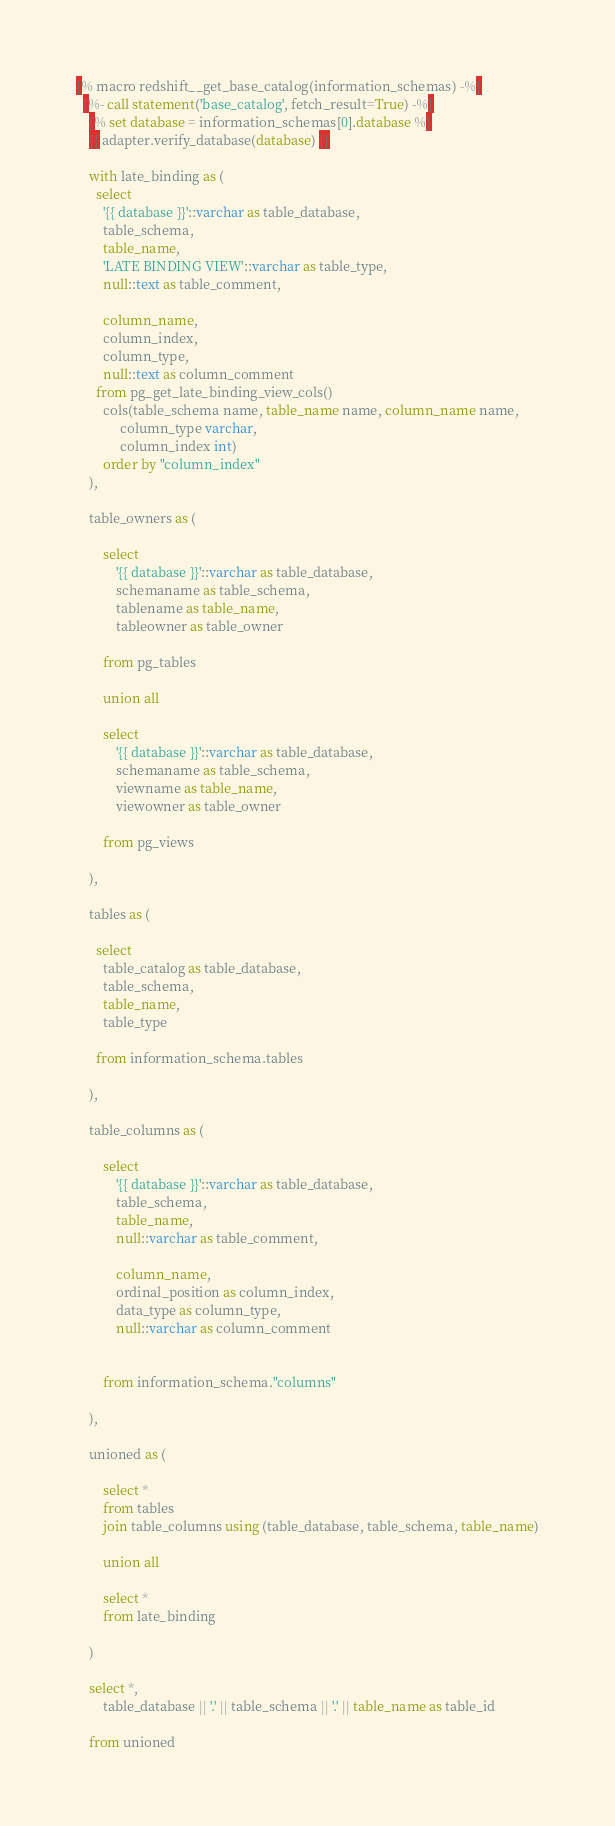<code> <loc_0><loc_0><loc_500><loc_500><_SQL_>
{% macro redshift__get_base_catalog(information_schemas) -%}
  {%- call statement('base_catalog', fetch_result=True) -%}
    {% set database = information_schemas[0].database %}
    {{ adapter.verify_database(database) }}

    with late_binding as (
      select
        '{{ database }}'::varchar as table_database,
        table_schema,
        table_name,
        'LATE BINDING VIEW'::varchar as table_type,
        null::text as table_comment,

        column_name,
        column_index,
        column_type,
        null::text as column_comment
      from pg_get_late_binding_view_cols()
        cols(table_schema name, table_name name, column_name name,
             column_type varchar,
             column_index int)
        order by "column_index"
    ),

    table_owners as (

        select
            '{{ database }}'::varchar as table_database,
            schemaname as table_schema,
            tablename as table_name,
            tableowner as table_owner

        from pg_tables

        union all

        select
            '{{ database }}'::varchar as table_database,
            schemaname as table_schema,
            viewname as table_name,
            viewowner as table_owner

        from pg_views

    ),

    tables as (

      select
        table_catalog as table_database,
        table_schema,
        table_name,
        table_type

      from information_schema.tables

    ),

    table_columns as (

        select
            '{{ database }}'::varchar as table_database,
            table_schema,
            table_name,
            null::varchar as table_comment,

            column_name,
            ordinal_position as column_index,
            data_type as column_type,
            null::varchar as column_comment


        from information_schema."columns"

    ),

    unioned as (

        select *
        from tables
        join table_columns using (table_database, table_schema, table_name)

        union all

        select *
        from late_binding

    )

    select *,
        table_database || '.' || table_schema || '.' || table_name as table_id

    from unioned</code> 